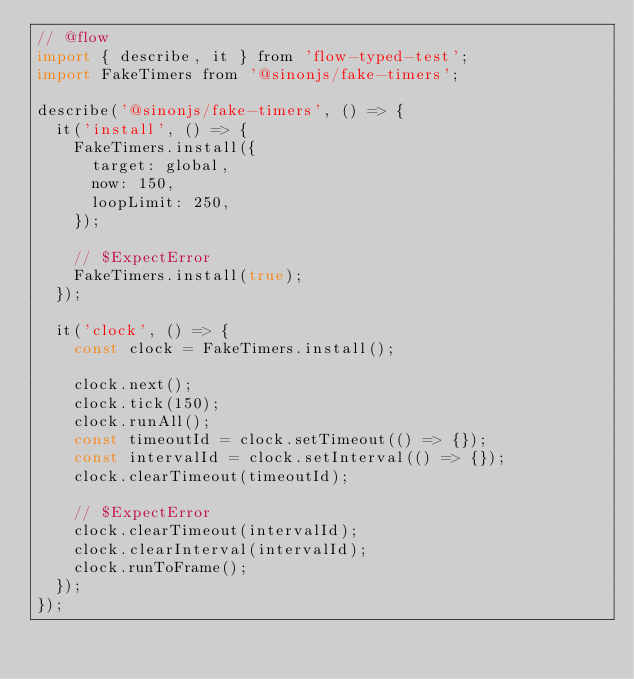Convert code to text. <code><loc_0><loc_0><loc_500><loc_500><_JavaScript_>// @flow
import { describe, it } from 'flow-typed-test';
import FakeTimers from '@sinonjs/fake-timers';

describe('@sinonjs/fake-timers', () => {
  it('install', () => {
    FakeTimers.install({
      target: global,
      now: 150,
      loopLimit: 250,
    });

    // $ExpectError
    FakeTimers.install(true);
  });

  it('clock', () => {
    const clock = FakeTimers.install();

    clock.next();
    clock.tick(150);
    clock.runAll();
    const timeoutId = clock.setTimeout(() => {});
    const intervalId = clock.setInterval(() => {});
    clock.clearTimeout(timeoutId);

    // $ExpectError
    clock.clearTimeout(intervalId);
    clock.clearInterval(intervalId);
    clock.runToFrame();
  });
});
</code> 